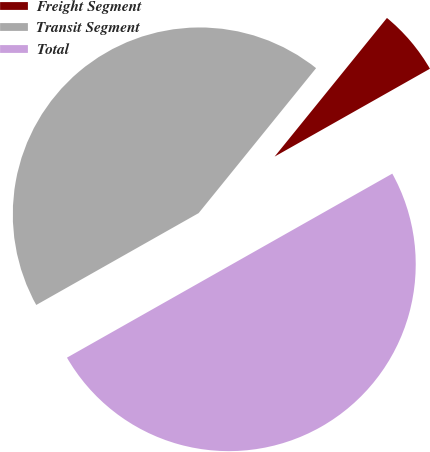<chart> <loc_0><loc_0><loc_500><loc_500><pie_chart><fcel>Freight Segment<fcel>Transit Segment<fcel>Total<nl><fcel>5.97%<fcel>44.03%<fcel>50.0%<nl></chart> 